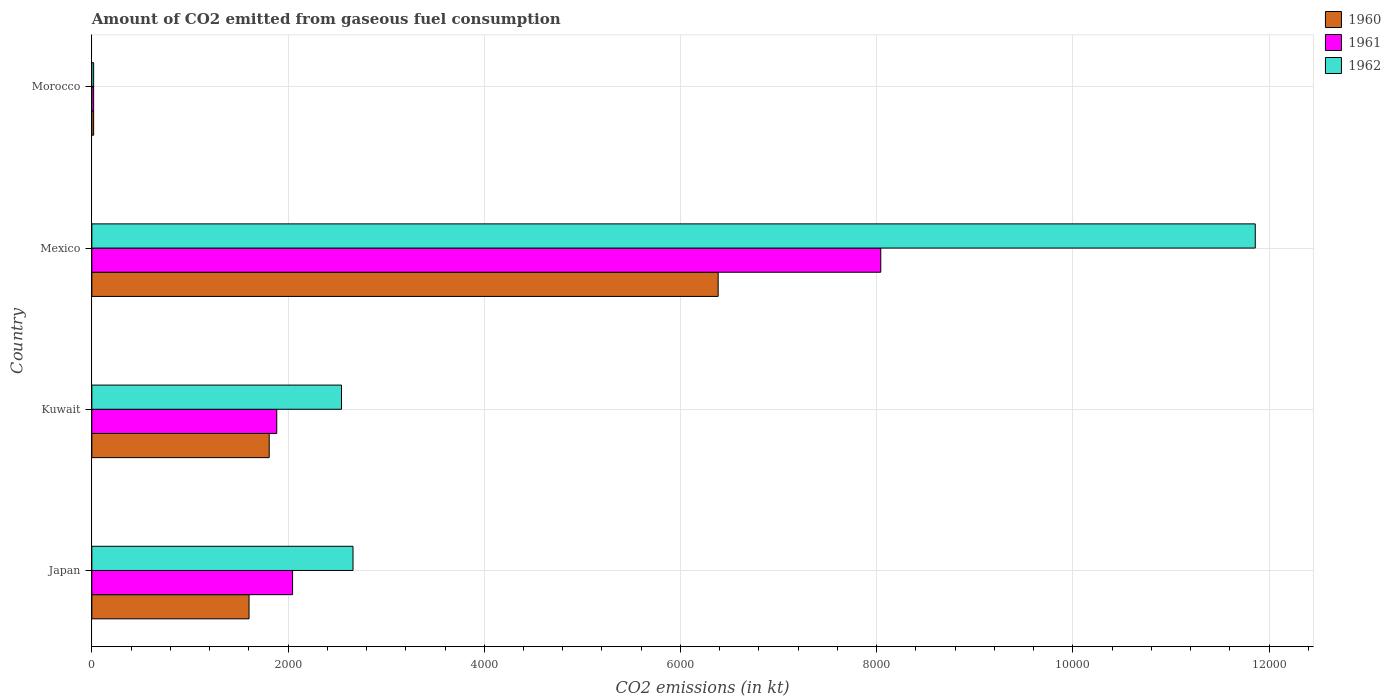Are the number of bars per tick equal to the number of legend labels?
Your response must be concise. Yes. Are the number of bars on each tick of the Y-axis equal?
Your answer should be compact. Yes. How many bars are there on the 2nd tick from the top?
Offer a very short reply. 3. How many bars are there on the 4th tick from the bottom?
Your answer should be compact. 3. What is the label of the 3rd group of bars from the top?
Keep it short and to the point. Kuwait. In how many cases, is the number of bars for a given country not equal to the number of legend labels?
Provide a succinct answer. 0. What is the amount of CO2 emitted in 1960 in Morocco?
Your answer should be compact. 18.34. Across all countries, what is the maximum amount of CO2 emitted in 1961?
Provide a short and direct response. 8041.73. Across all countries, what is the minimum amount of CO2 emitted in 1960?
Give a very brief answer. 18.34. In which country was the amount of CO2 emitted in 1962 maximum?
Your answer should be very brief. Mexico. In which country was the amount of CO2 emitted in 1961 minimum?
Offer a terse response. Morocco. What is the total amount of CO2 emitted in 1962 in the graph?
Offer a terse response. 1.71e+04. What is the difference between the amount of CO2 emitted in 1961 in Japan and that in Mexico?
Your answer should be compact. -5995.55. What is the difference between the amount of CO2 emitted in 1962 in Japan and the amount of CO2 emitted in 1960 in Morocco?
Your answer should be compact. 2643.91. What is the average amount of CO2 emitted in 1960 per country?
Provide a short and direct response. 2453.22. What is the difference between the amount of CO2 emitted in 1961 and amount of CO2 emitted in 1960 in Japan?
Offer a terse response. 443.71. In how many countries, is the amount of CO2 emitted in 1962 greater than 3600 kt?
Your answer should be very brief. 1. What is the ratio of the amount of CO2 emitted in 1962 in Japan to that in Morocco?
Offer a very short reply. 145.2. Is the amount of CO2 emitted in 1960 in Japan less than that in Mexico?
Provide a short and direct response. Yes. Is the difference between the amount of CO2 emitted in 1961 in Kuwait and Morocco greater than the difference between the amount of CO2 emitted in 1960 in Kuwait and Morocco?
Offer a very short reply. Yes. What is the difference between the highest and the second highest amount of CO2 emitted in 1961?
Keep it short and to the point. 5995.55. What is the difference between the highest and the lowest amount of CO2 emitted in 1960?
Give a very brief answer. 6365.91. In how many countries, is the amount of CO2 emitted in 1960 greater than the average amount of CO2 emitted in 1960 taken over all countries?
Offer a terse response. 1. Is the sum of the amount of CO2 emitted in 1960 in Japan and Morocco greater than the maximum amount of CO2 emitted in 1961 across all countries?
Give a very brief answer. No. Is it the case that in every country, the sum of the amount of CO2 emitted in 1961 and amount of CO2 emitted in 1962 is greater than the amount of CO2 emitted in 1960?
Keep it short and to the point. Yes. How many bars are there?
Offer a very short reply. 12. How many countries are there in the graph?
Your answer should be compact. 4. What is the difference between two consecutive major ticks on the X-axis?
Your answer should be very brief. 2000. Does the graph contain grids?
Offer a very short reply. Yes. Where does the legend appear in the graph?
Offer a terse response. Top right. What is the title of the graph?
Keep it short and to the point. Amount of CO2 emitted from gaseous fuel consumption. Does "1983" appear as one of the legend labels in the graph?
Offer a terse response. No. What is the label or title of the X-axis?
Keep it short and to the point. CO2 emissions (in kt). What is the label or title of the Y-axis?
Offer a terse response. Country. What is the CO2 emissions (in kt) of 1960 in Japan?
Make the answer very short. 1602.48. What is the CO2 emissions (in kt) in 1961 in Japan?
Provide a succinct answer. 2046.19. What is the CO2 emissions (in kt) of 1962 in Japan?
Offer a terse response. 2662.24. What is the CO2 emissions (in kt) of 1960 in Kuwait?
Provide a succinct answer. 1807.83. What is the CO2 emissions (in kt) in 1961 in Kuwait?
Offer a very short reply. 1884.84. What is the CO2 emissions (in kt) in 1962 in Kuwait?
Give a very brief answer. 2544.9. What is the CO2 emissions (in kt) of 1960 in Mexico?
Your answer should be compact. 6384.25. What is the CO2 emissions (in kt) in 1961 in Mexico?
Keep it short and to the point. 8041.73. What is the CO2 emissions (in kt) in 1962 in Mexico?
Make the answer very short. 1.19e+04. What is the CO2 emissions (in kt) of 1960 in Morocco?
Provide a succinct answer. 18.34. What is the CO2 emissions (in kt) of 1961 in Morocco?
Your response must be concise. 18.34. What is the CO2 emissions (in kt) in 1962 in Morocco?
Keep it short and to the point. 18.34. Across all countries, what is the maximum CO2 emissions (in kt) in 1960?
Your response must be concise. 6384.25. Across all countries, what is the maximum CO2 emissions (in kt) in 1961?
Provide a succinct answer. 8041.73. Across all countries, what is the maximum CO2 emissions (in kt) of 1962?
Ensure brevity in your answer.  1.19e+04. Across all countries, what is the minimum CO2 emissions (in kt) in 1960?
Your answer should be very brief. 18.34. Across all countries, what is the minimum CO2 emissions (in kt) of 1961?
Your response must be concise. 18.34. Across all countries, what is the minimum CO2 emissions (in kt) in 1962?
Ensure brevity in your answer.  18.34. What is the total CO2 emissions (in kt) in 1960 in the graph?
Offer a terse response. 9812.89. What is the total CO2 emissions (in kt) in 1961 in the graph?
Offer a terse response. 1.20e+04. What is the total CO2 emissions (in kt) of 1962 in the graph?
Give a very brief answer. 1.71e+04. What is the difference between the CO2 emissions (in kt) of 1960 in Japan and that in Kuwait?
Your answer should be compact. -205.35. What is the difference between the CO2 emissions (in kt) in 1961 in Japan and that in Kuwait?
Offer a terse response. 161.35. What is the difference between the CO2 emissions (in kt) of 1962 in Japan and that in Kuwait?
Ensure brevity in your answer.  117.34. What is the difference between the CO2 emissions (in kt) of 1960 in Japan and that in Mexico?
Your response must be concise. -4781.77. What is the difference between the CO2 emissions (in kt) in 1961 in Japan and that in Mexico?
Make the answer very short. -5995.55. What is the difference between the CO2 emissions (in kt) in 1962 in Japan and that in Mexico?
Offer a terse response. -9196.84. What is the difference between the CO2 emissions (in kt) of 1960 in Japan and that in Morocco?
Your answer should be very brief. 1584.14. What is the difference between the CO2 emissions (in kt) in 1961 in Japan and that in Morocco?
Your answer should be very brief. 2027.85. What is the difference between the CO2 emissions (in kt) in 1962 in Japan and that in Morocco?
Your response must be concise. 2643.91. What is the difference between the CO2 emissions (in kt) in 1960 in Kuwait and that in Mexico?
Keep it short and to the point. -4576.42. What is the difference between the CO2 emissions (in kt) of 1961 in Kuwait and that in Mexico?
Give a very brief answer. -6156.89. What is the difference between the CO2 emissions (in kt) of 1962 in Kuwait and that in Mexico?
Your answer should be very brief. -9314.18. What is the difference between the CO2 emissions (in kt) of 1960 in Kuwait and that in Morocco?
Offer a terse response. 1789.5. What is the difference between the CO2 emissions (in kt) of 1961 in Kuwait and that in Morocco?
Give a very brief answer. 1866.5. What is the difference between the CO2 emissions (in kt) of 1962 in Kuwait and that in Morocco?
Ensure brevity in your answer.  2526.56. What is the difference between the CO2 emissions (in kt) of 1960 in Mexico and that in Morocco?
Your answer should be compact. 6365.91. What is the difference between the CO2 emissions (in kt) of 1961 in Mexico and that in Morocco?
Make the answer very short. 8023.4. What is the difference between the CO2 emissions (in kt) of 1962 in Mexico and that in Morocco?
Your answer should be very brief. 1.18e+04. What is the difference between the CO2 emissions (in kt) in 1960 in Japan and the CO2 emissions (in kt) in 1961 in Kuwait?
Ensure brevity in your answer.  -282.36. What is the difference between the CO2 emissions (in kt) of 1960 in Japan and the CO2 emissions (in kt) of 1962 in Kuwait?
Provide a succinct answer. -942.42. What is the difference between the CO2 emissions (in kt) of 1961 in Japan and the CO2 emissions (in kt) of 1962 in Kuwait?
Your answer should be very brief. -498.71. What is the difference between the CO2 emissions (in kt) of 1960 in Japan and the CO2 emissions (in kt) of 1961 in Mexico?
Offer a terse response. -6439.25. What is the difference between the CO2 emissions (in kt) of 1960 in Japan and the CO2 emissions (in kt) of 1962 in Mexico?
Give a very brief answer. -1.03e+04. What is the difference between the CO2 emissions (in kt) of 1961 in Japan and the CO2 emissions (in kt) of 1962 in Mexico?
Offer a terse response. -9812.89. What is the difference between the CO2 emissions (in kt) of 1960 in Japan and the CO2 emissions (in kt) of 1961 in Morocco?
Offer a terse response. 1584.14. What is the difference between the CO2 emissions (in kt) in 1960 in Japan and the CO2 emissions (in kt) in 1962 in Morocco?
Make the answer very short. 1584.14. What is the difference between the CO2 emissions (in kt) of 1961 in Japan and the CO2 emissions (in kt) of 1962 in Morocco?
Keep it short and to the point. 2027.85. What is the difference between the CO2 emissions (in kt) of 1960 in Kuwait and the CO2 emissions (in kt) of 1961 in Mexico?
Your answer should be compact. -6233.9. What is the difference between the CO2 emissions (in kt) of 1960 in Kuwait and the CO2 emissions (in kt) of 1962 in Mexico?
Provide a succinct answer. -1.01e+04. What is the difference between the CO2 emissions (in kt) in 1961 in Kuwait and the CO2 emissions (in kt) in 1962 in Mexico?
Your answer should be very brief. -9974.24. What is the difference between the CO2 emissions (in kt) of 1960 in Kuwait and the CO2 emissions (in kt) of 1961 in Morocco?
Your answer should be very brief. 1789.5. What is the difference between the CO2 emissions (in kt) in 1960 in Kuwait and the CO2 emissions (in kt) in 1962 in Morocco?
Your answer should be compact. 1789.5. What is the difference between the CO2 emissions (in kt) in 1961 in Kuwait and the CO2 emissions (in kt) in 1962 in Morocco?
Make the answer very short. 1866.5. What is the difference between the CO2 emissions (in kt) of 1960 in Mexico and the CO2 emissions (in kt) of 1961 in Morocco?
Your answer should be compact. 6365.91. What is the difference between the CO2 emissions (in kt) of 1960 in Mexico and the CO2 emissions (in kt) of 1962 in Morocco?
Offer a very short reply. 6365.91. What is the difference between the CO2 emissions (in kt) of 1961 in Mexico and the CO2 emissions (in kt) of 1962 in Morocco?
Your response must be concise. 8023.4. What is the average CO2 emissions (in kt) in 1960 per country?
Offer a terse response. 2453.22. What is the average CO2 emissions (in kt) of 1961 per country?
Make the answer very short. 2997.77. What is the average CO2 emissions (in kt) in 1962 per country?
Make the answer very short. 4271.14. What is the difference between the CO2 emissions (in kt) in 1960 and CO2 emissions (in kt) in 1961 in Japan?
Offer a very short reply. -443.71. What is the difference between the CO2 emissions (in kt) in 1960 and CO2 emissions (in kt) in 1962 in Japan?
Your answer should be very brief. -1059.76. What is the difference between the CO2 emissions (in kt) of 1961 and CO2 emissions (in kt) of 1962 in Japan?
Give a very brief answer. -616.06. What is the difference between the CO2 emissions (in kt) of 1960 and CO2 emissions (in kt) of 1961 in Kuwait?
Give a very brief answer. -77.01. What is the difference between the CO2 emissions (in kt) of 1960 and CO2 emissions (in kt) of 1962 in Kuwait?
Make the answer very short. -737.07. What is the difference between the CO2 emissions (in kt) in 1961 and CO2 emissions (in kt) in 1962 in Kuwait?
Make the answer very short. -660.06. What is the difference between the CO2 emissions (in kt) in 1960 and CO2 emissions (in kt) in 1961 in Mexico?
Your response must be concise. -1657.48. What is the difference between the CO2 emissions (in kt) of 1960 and CO2 emissions (in kt) of 1962 in Mexico?
Keep it short and to the point. -5474.83. What is the difference between the CO2 emissions (in kt) in 1961 and CO2 emissions (in kt) in 1962 in Mexico?
Your answer should be very brief. -3817.35. What is the difference between the CO2 emissions (in kt) in 1960 and CO2 emissions (in kt) in 1961 in Morocco?
Ensure brevity in your answer.  0. What is the difference between the CO2 emissions (in kt) of 1960 and CO2 emissions (in kt) of 1962 in Morocco?
Make the answer very short. 0. What is the difference between the CO2 emissions (in kt) in 1961 and CO2 emissions (in kt) in 1962 in Morocco?
Keep it short and to the point. 0. What is the ratio of the CO2 emissions (in kt) in 1960 in Japan to that in Kuwait?
Ensure brevity in your answer.  0.89. What is the ratio of the CO2 emissions (in kt) of 1961 in Japan to that in Kuwait?
Provide a short and direct response. 1.09. What is the ratio of the CO2 emissions (in kt) of 1962 in Japan to that in Kuwait?
Give a very brief answer. 1.05. What is the ratio of the CO2 emissions (in kt) of 1960 in Japan to that in Mexico?
Give a very brief answer. 0.25. What is the ratio of the CO2 emissions (in kt) in 1961 in Japan to that in Mexico?
Keep it short and to the point. 0.25. What is the ratio of the CO2 emissions (in kt) in 1962 in Japan to that in Mexico?
Provide a succinct answer. 0.22. What is the ratio of the CO2 emissions (in kt) of 1960 in Japan to that in Morocco?
Make the answer very short. 87.4. What is the ratio of the CO2 emissions (in kt) of 1961 in Japan to that in Morocco?
Offer a terse response. 111.6. What is the ratio of the CO2 emissions (in kt) of 1962 in Japan to that in Morocco?
Your response must be concise. 145.2. What is the ratio of the CO2 emissions (in kt) of 1960 in Kuwait to that in Mexico?
Offer a terse response. 0.28. What is the ratio of the CO2 emissions (in kt) of 1961 in Kuwait to that in Mexico?
Give a very brief answer. 0.23. What is the ratio of the CO2 emissions (in kt) of 1962 in Kuwait to that in Mexico?
Provide a short and direct response. 0.21. What is the ratio of the CO2 emissions (in kt) of 1960 in Kuwait to that in Morocco?
Offer a terse response. 98.6. What is the ratio of the CO2 emissions (in kt) of 1961 in Kuwait to that in Morocco?
Ensure brevity in your answer.  102.8. What is the ratio of the CO2 emissions (in kt) of 1962 in Kuwait to that in Morocco?
Your answer should be very brief. 138.8. What is the ratio of the CO2 emissions (in kt) in 1960 in Mexico to that in Morocco?
Offer a very short reply. 348.2. What is the ratio of the CO2 emissions (in kt) of 1961 in Mexico to that in Morocco?
Ensure brevity in your answer.  438.6. What is the ratio of the CO2 emissions (in kt) of 1962 in Mexico to that in Morocco?
Offer a very short reply. 646.8. What is the difference between the highest and the second highest CO2 emissions (in kt) in 1960?
Your answer should be very brief. 4576.42. What is the difference between the highest and the second highest CO2 emissions (in kt) in 1961?
Offer a very short reply. 5995.55. What is the difference between the highest and the second highest CO2 emissions (in kt) of 1962?
Your answer should be very brief. 9196.84. What is the difference between the highest and the lowest CO2 emissions (in kt) in 1960?
Provide a succinct answer. 6365.91. What is the difference between the highest and the lowest CO2 emissions (in kt) in 1961?
Your answer should be compact. 8023.4. What is the difference between the highest and the lowest CO2 emissions (in kt) of 1962?
Offer a terse response. 1.18e+04. 